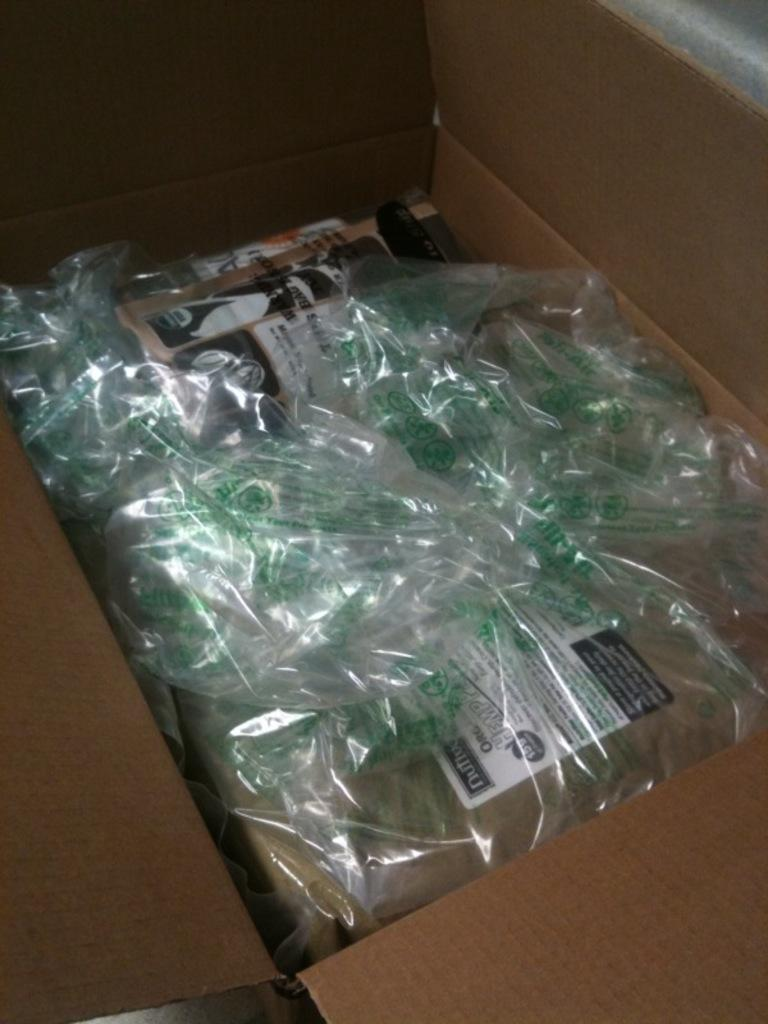What objects are present in the image? There are boxes in the image. Can you describe the contents of one of the boxes? There is a polythene cover in a carton box. What type of island can be seen in the background of the image? There is no island present in the image; it only features boxes and a polythene cover in a carton box. What time of day is depicted in the image, considering the presence of eggnog? There is no mention of eggnog in the image, and therefore it cannot be used to determine the time of day. 